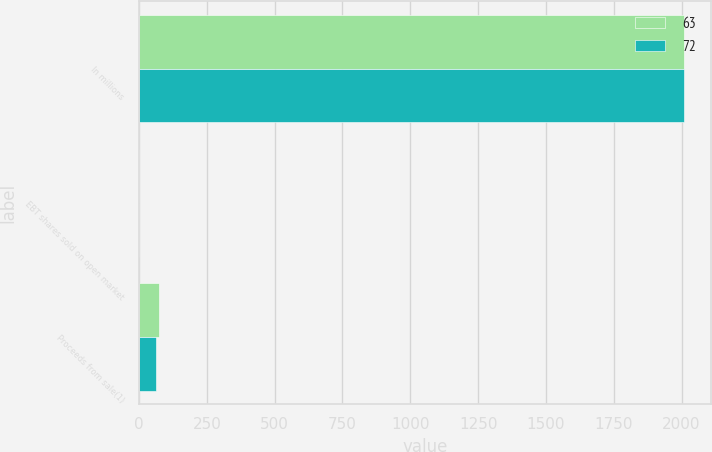Convert chart. <chart><loc_0><loc_0><loc_500><loc_500><stacked_bar_chart><ecel><fcel>In millions<fcel>EBT shares sold on open market<fcel>Proceeds from sale(1)<nl><fcel>63<fcel>2009<fcel>1.5<fcel>72<nl><fcel>72<fcel>2008<fcel>1.4<fcel>63<nl></chart> 